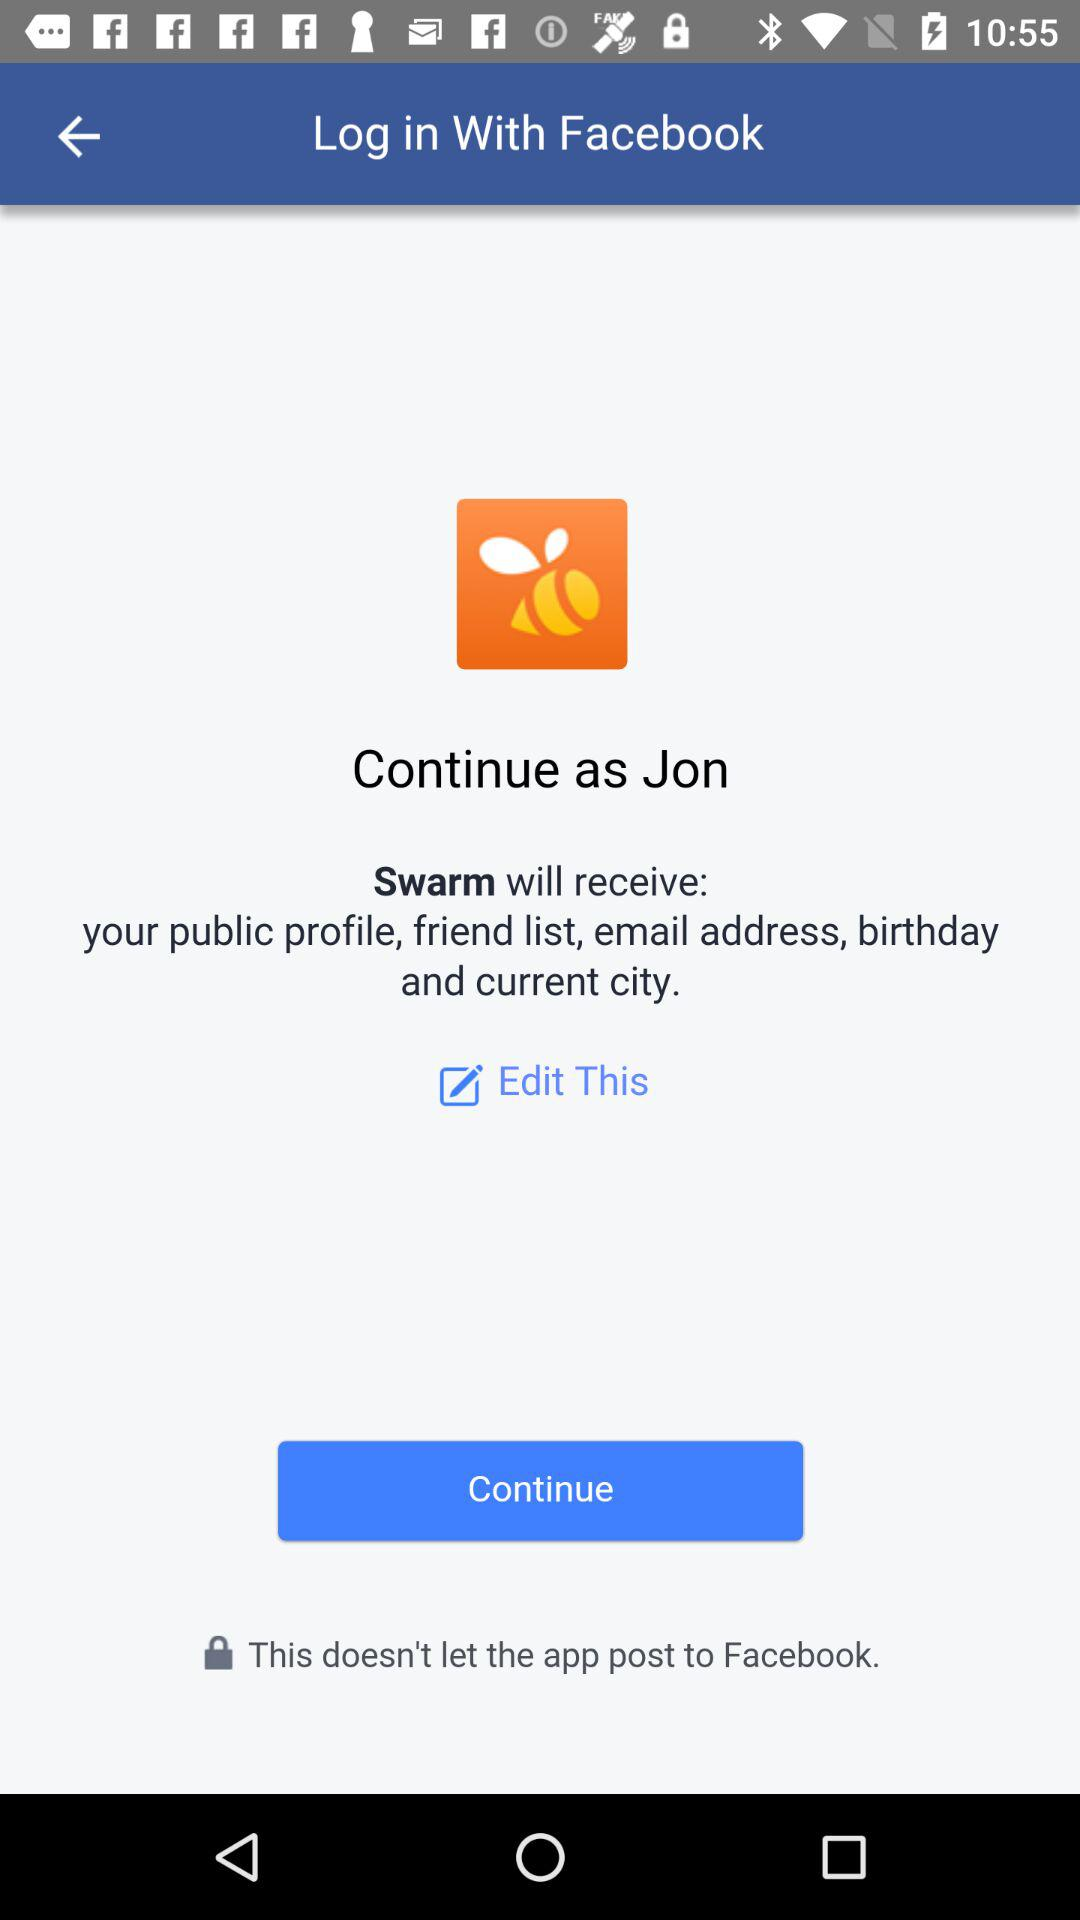What application is asking for permission? The application asking for permission is "Swarm". 